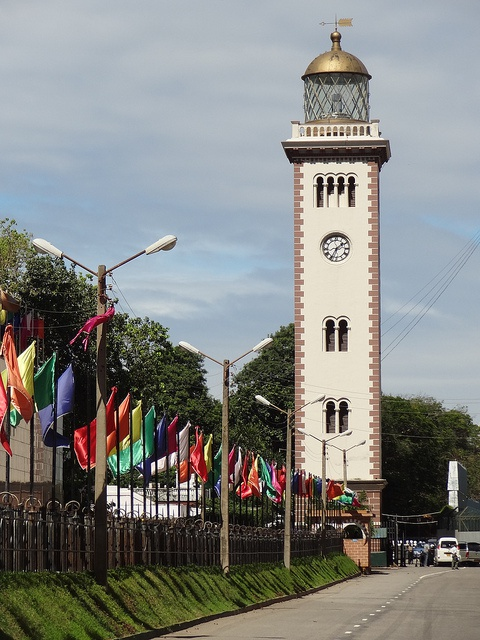Describe the objects in this image and their specific colors. I can see clock in darkgray, ivory, gray, and black tones, car in darkgray, black, gray, and maroon tones, truck in darkgray, ivory, black, gray, and beige tones, people in darkgray, black, gray, and ivory tones, and people in darkgray, black, and gray tones in this image. 